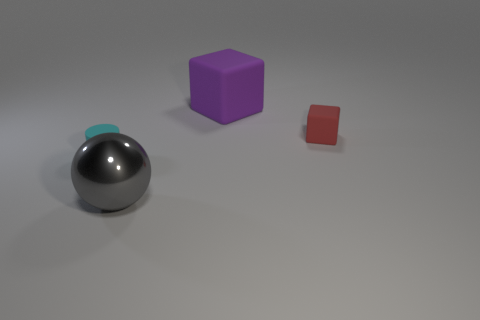Add 1 rubber objects. How many objects exist? 5 Subtract all cylinders. How many objects are left? 3 Subtract all shiny things. Subtract all small brown cylinders. How many objects are left? 3 Add 1 small rubber cylinders. How many small rubber cylinders are left? 2 Add 3 big green cylinders. How many big green cylinders exist? 3 Subtract 0 brown cubes. How many objects are left? 4 